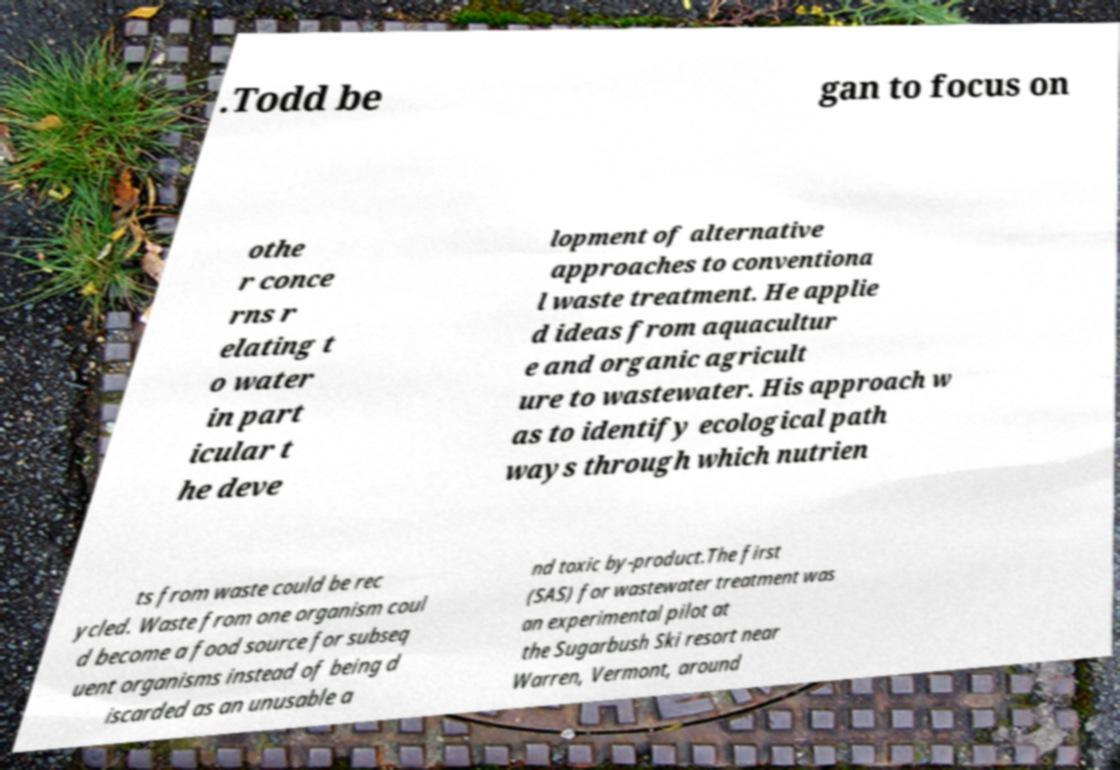Please identify and transcribe the text found in this image. .Todd be gan to focus on othe r conce rns r elating t o water in part icular t he deve lopment of alternative approaches to conventiona l waste treatment. He applie d ideas from aquacultur e and organic agricult ure to wastewater. His approach w as to identify ecological path ways through which nutrien ts from waste could be rec ycled. Waste from one organism coul d become a food source for subseq uent organisms instead of being d iscarded as an unusable a nd toxic by-product.The first (SAS) for wastewater treatment was an experimental pilot at the Sugarbush Ski resort near Warren, Vermont, around 